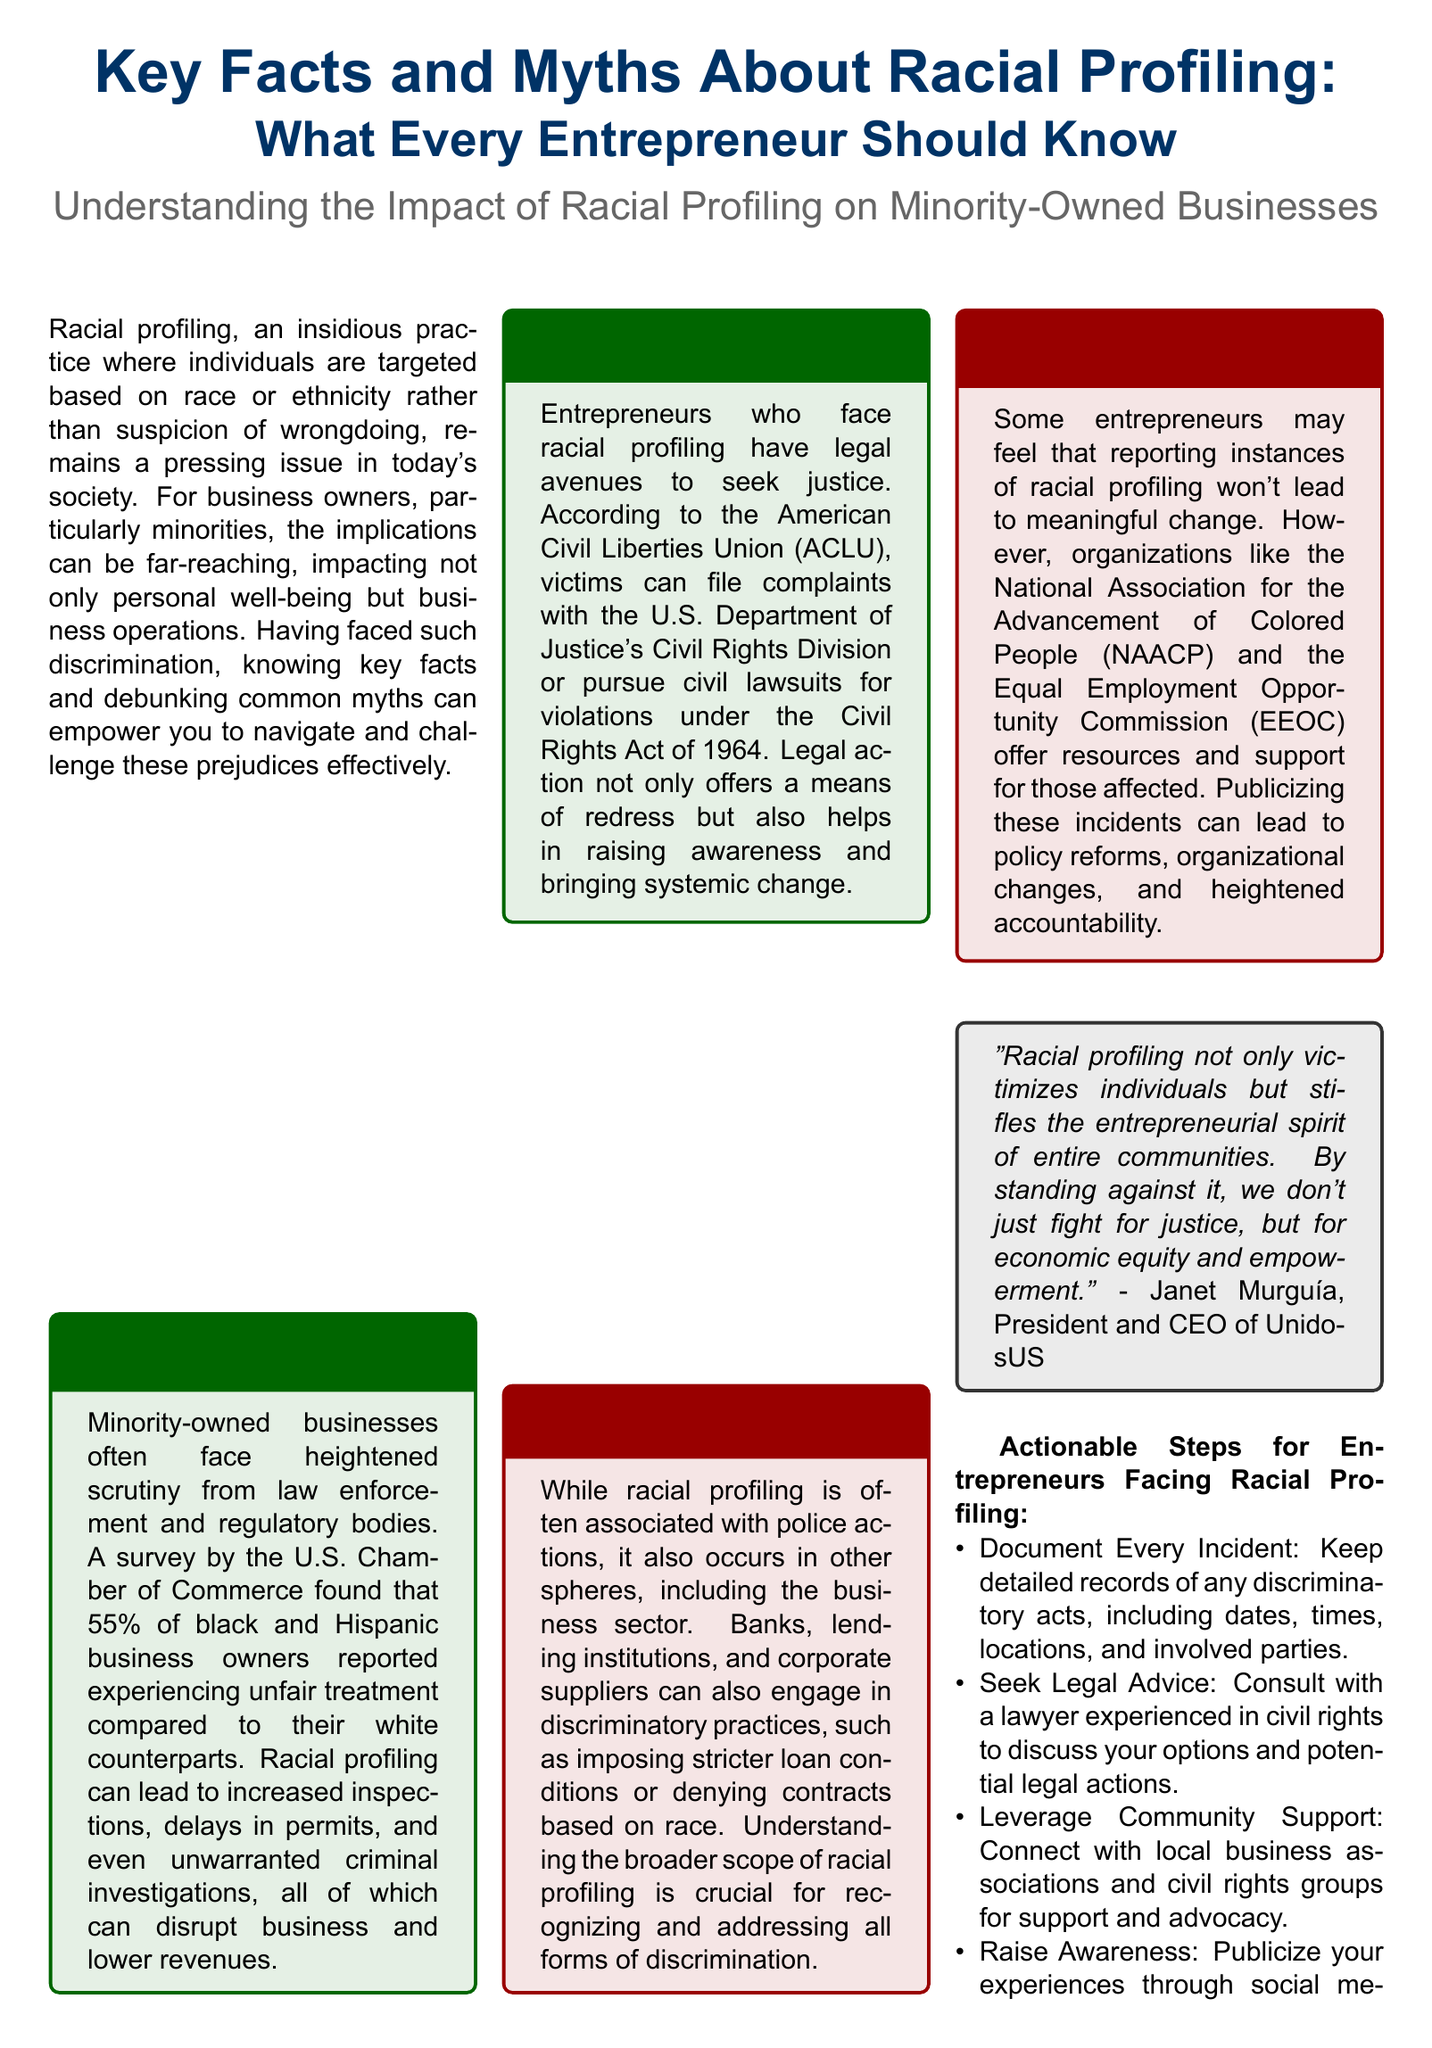What percentage of black and Hispanic business owners reported unfair treatment? The document states that a survey by the U.S. Chamber of Commerce found that 55% of black and Hispanic business owners reported experiencing unfair treatment.
Answer: 55% What legal avenues are available for entrepreneurs facing racial profiling? The document mentions that victims can file complaints with the U.S. Department of Justice's Civil Rights Division or pursue civil lawsuits under the Civil Rights Act of 1964.
Answer: Legal avenues Which organizations offer support for reporting racial profiling? The document highlights organizations like the NAACP and the EEOC that provide resources and support for those affected by racial profiling.
Answer: NAACP and EEOC What is the myth regarding the scope of racial profiling? The document explains that a common myth is that racial profiling only involves law enforcement, while it actually occurs in other areas as well.
Answer: Law enforcement only What is the actionable step that suggests documenting incidents? The document instructs to keep detailed records of any discriminatory acts, including dates, times, locations, and involved parties.
Answer: Document Every Incident Who stated that racial profiling stifles the entrepreneurial spirit of communities? Janet Murguía, the President and CEO of UnidosUS, is quoted in the document about the impact of racial profiling on communities.
Answer: Janet Murguía What document type is this layout classified as? The layout aligns with a newspaper format that seeks to inform readers about racial profiling and its implications for entrepreneurs.
Answer: Newspaper layout How does racial profiling impact business operations according to the document? It leads to increased inspections, delays in permits, and unwarranted criminal investigations that disrupt business and lower revenues.
Answer: Disrupts business and lowers revenues 